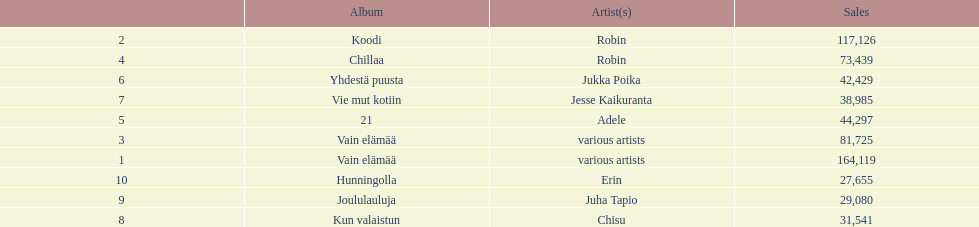What was the top selling album in this year? Vain elämää. 